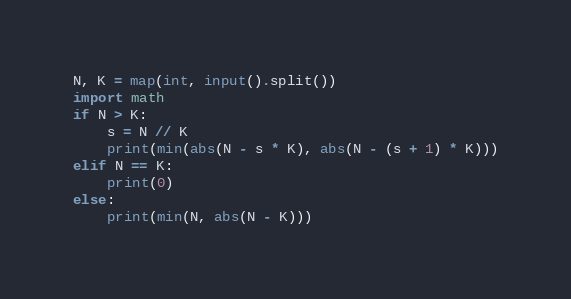Convert code to text. <code><loc_0><loc_0><loc_500><loc_500><_Python_>N, K = map(int, input().split())
import math
if N > K:
    s = N // K
    print(min(abs(N - s * K), abs(N - (s + 1) * K)))
elif N == K:
    print(0)
else:
    print(min(N, abs(N - K)))</code> 